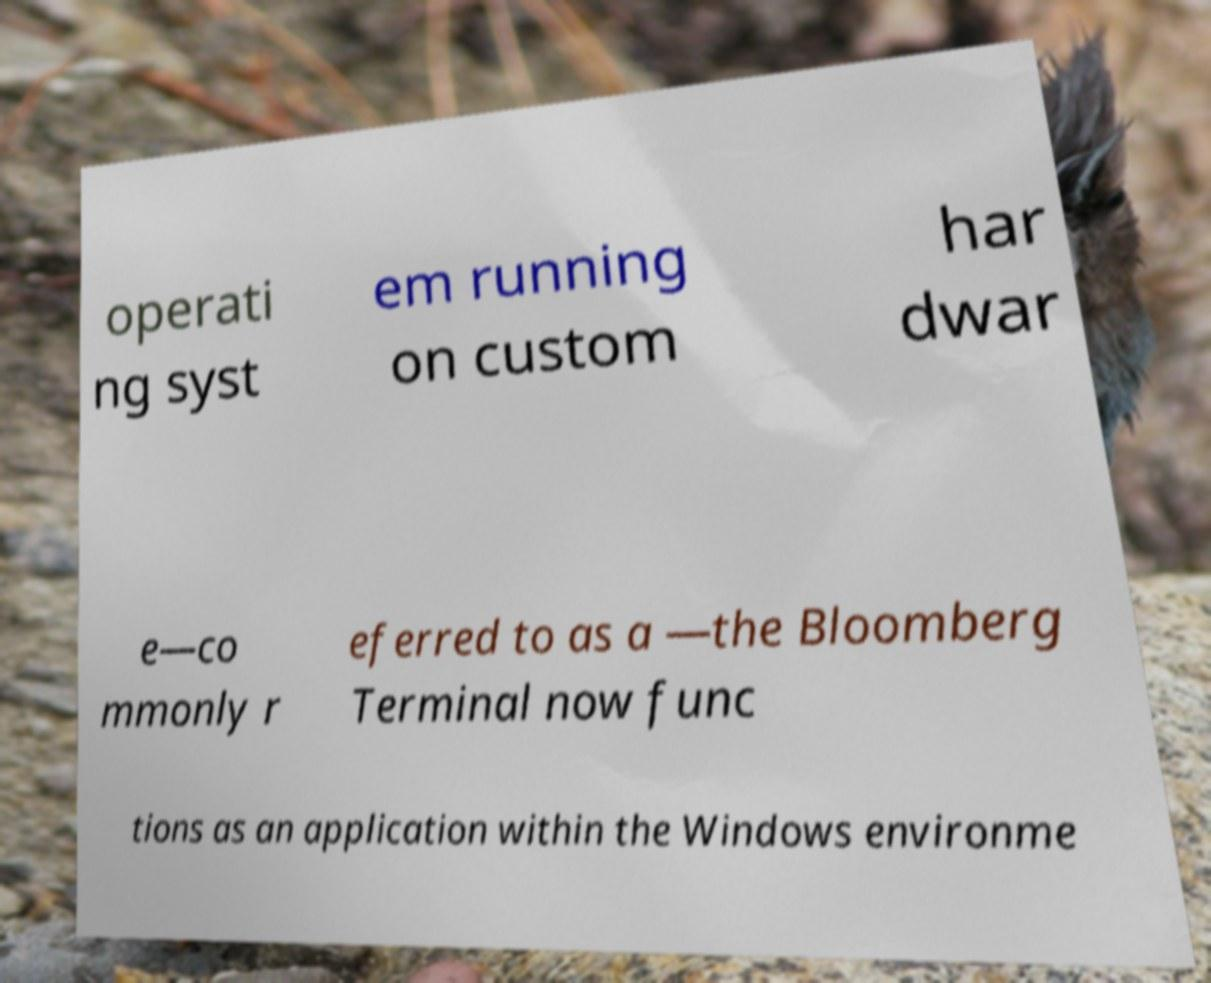Please identify and transcribe the text found in this image. operati ng syst em running on custom har dwar e—co mmonly r eferred to as a —the Bloomberg Terminal now func tions as an application within the Windows environme 